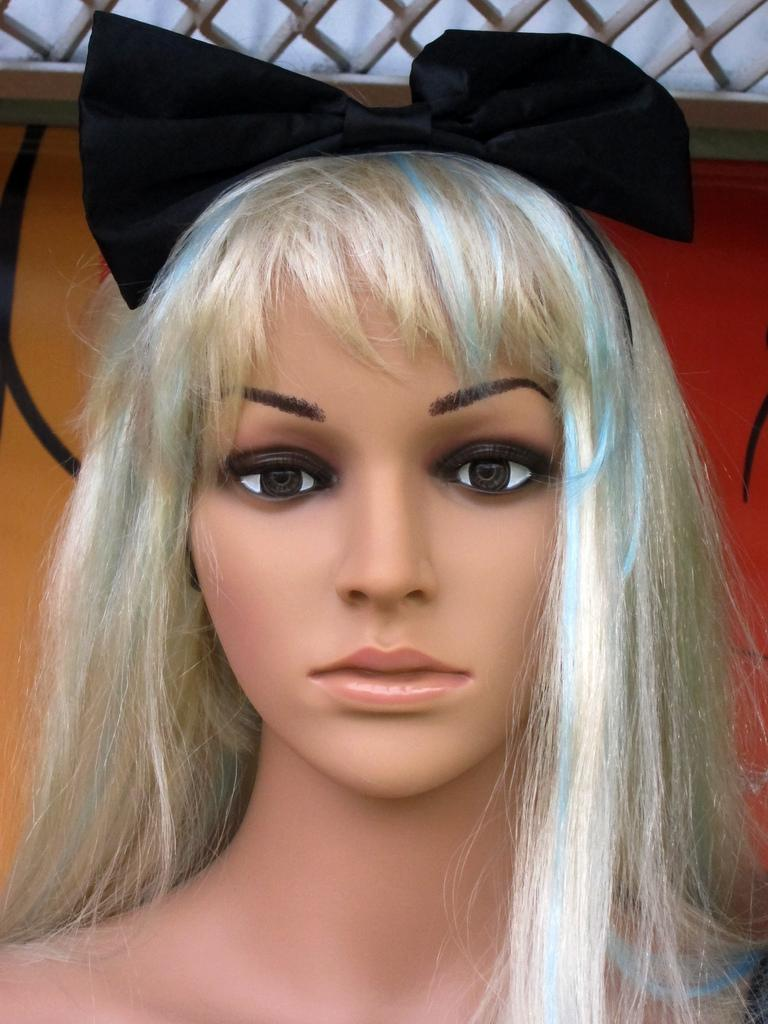What is the main subject of the image? There is a doll in the image. What type of boot is the laborer wearing in the image? There is no laborer or boot present in the image; it only features a doll. 